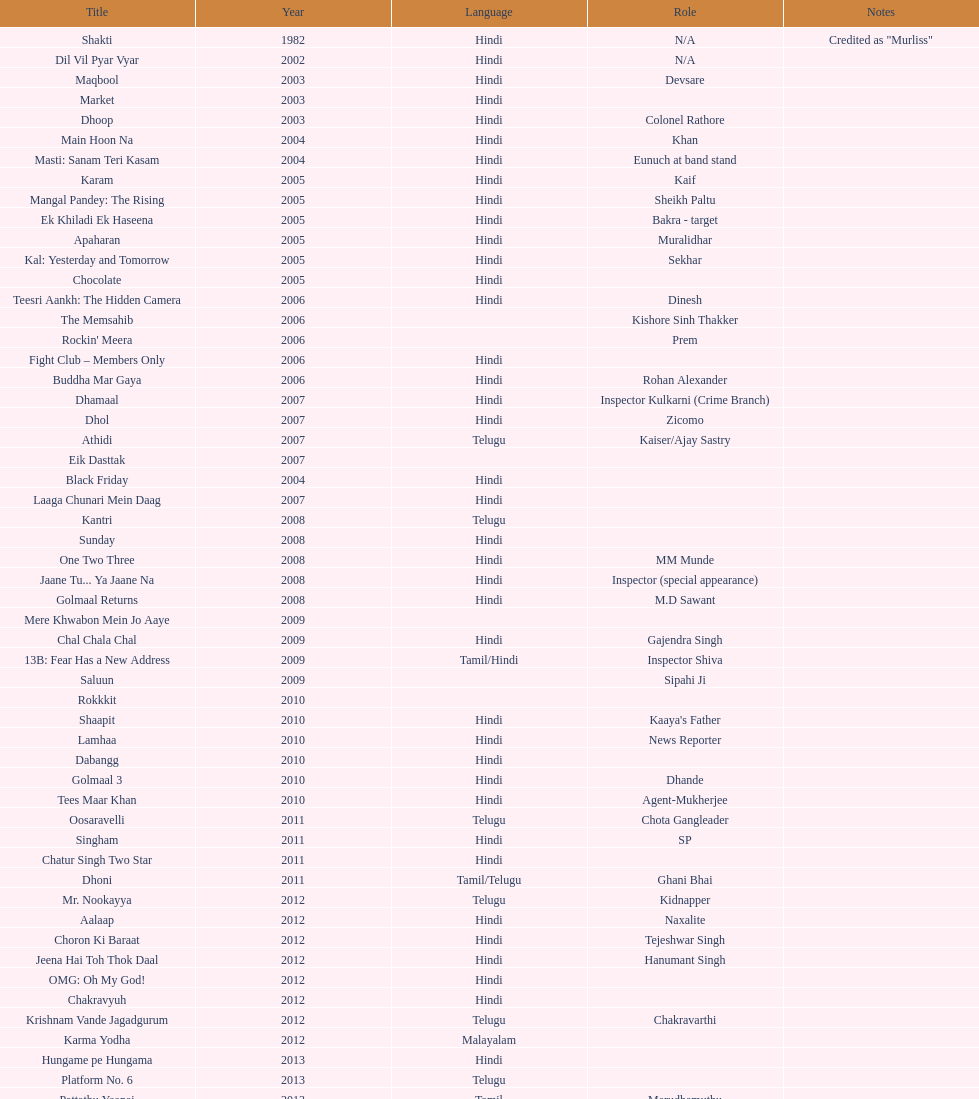How many characters has this actor portrayed? 36. 